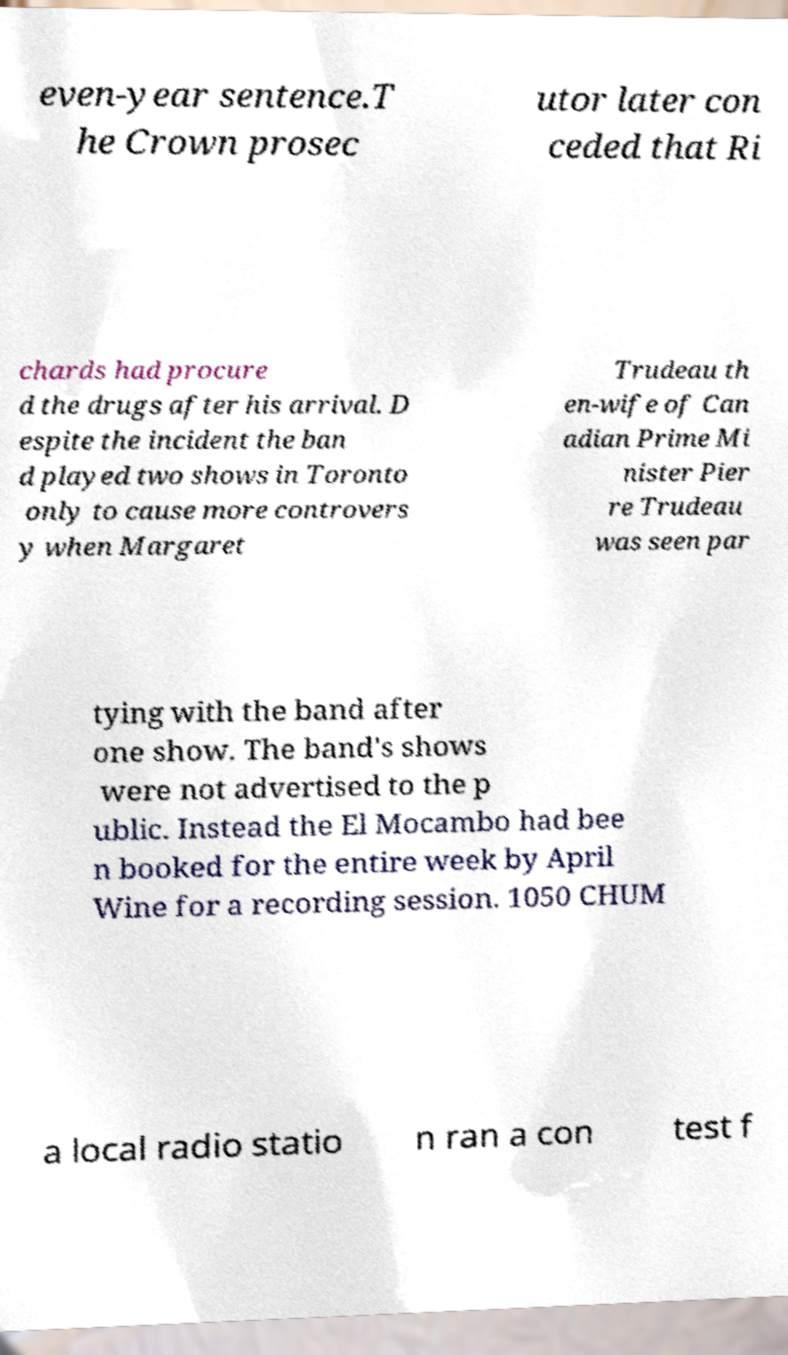There's text embedded in this image that I need extracted. Can you transcribe it verbatim? even-year sentence.T he Crown prosec utor later con ceded that Ri chards had procure d the drugs after his arrival. D espite the incident the ban d played two shows in Toronto only to cause more controvers y when Margaret Trudeau th en-wife of Can adian Prime Mi nister Pier re Trudeau was seen par tying with the band after one show. The band's shows were not advertised to the p ublic. Instead the El Mocambo had bee n booked for the entire week by April Wine for a recording session. 1050 CHUM a local radio statio n ran a con test f 